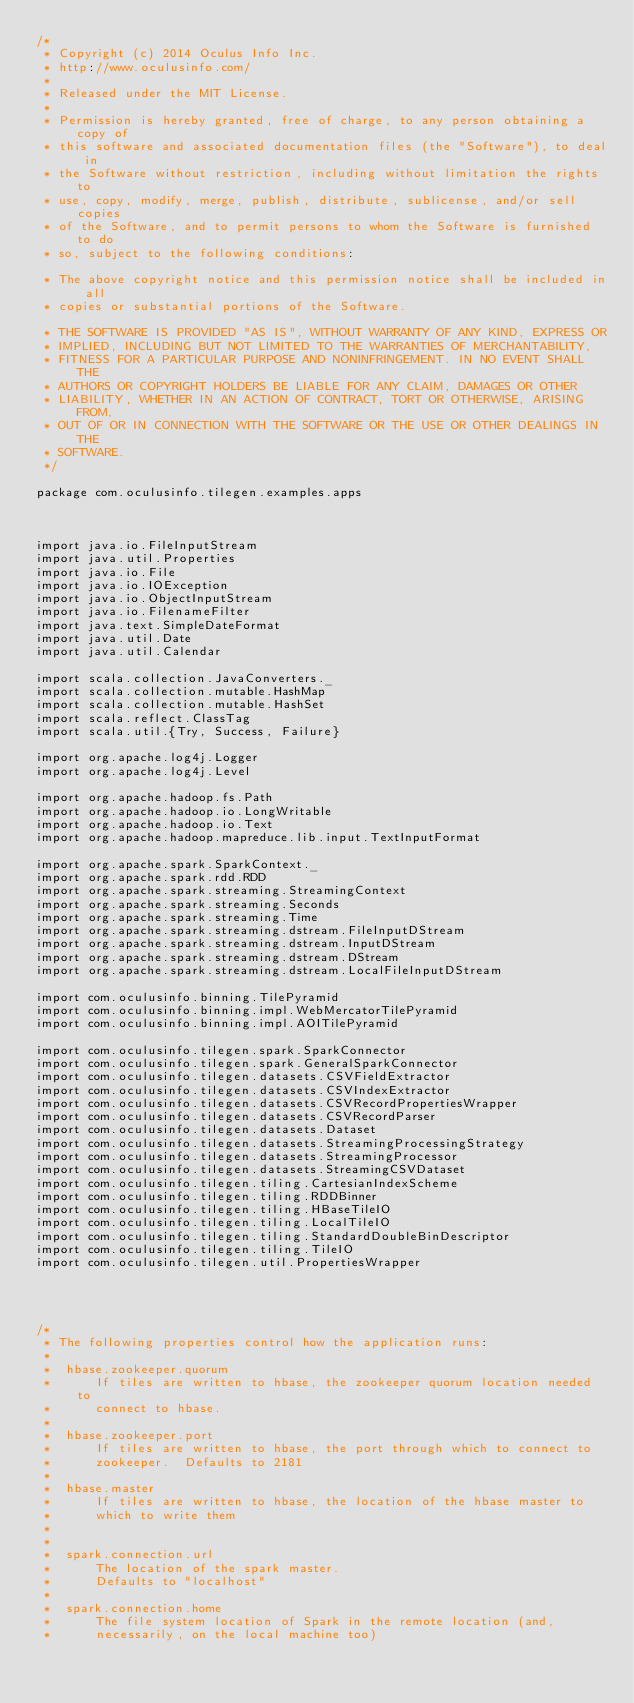Convert code to text. <code><loc_0><loc_0><loc_500><loc_500><_Scala_>/*
 * Copyright (c) 2014 Oculus Info Inc.
 * http://www.oculusinfo.com/
 *
 * Released under the MIT License.
 *
 * Permission is hereby granted, free of charge, to any person obtaining a copy of
 * this software and associated documentation files (the "Software"), to deal in
 * the Software without restriction, including without limitation the rights to
 * use, copy, modify, merge, publish, distribute, sublicense, and/or sell copies
 * of the Software, and to permit persons to whom the Software is furnished to do
 * so, subject to the following conditions:

 * The above copyright notice and this permission notice shall be included in all
 * copies or substantial portions of the Software.

 * THE SOFTWARE IS PROVIDED "AS IS", WITHOUT WARRANTY OF ANY KIND, EXPRESS OR
 * IMPLIED, INCLUDING BUT NOT LIMITED TO THE WARRANTIES OF MERCHANTABILITY,
 * FITNESS FOR A PARTICULAR PURPOSE AND NONINFRINGEMENT. IN NO EVENT SHALL THE
 * AUTHORS OR COPYRIGHT HOLDERS BE LIABLE FOR ANY CLAIM, DAMAGES OR OTHER
 * LIABILITY, WHETHER IN AN ACTION OF CONTRACT, TORT OR OTHERWISE, ARISING FROM,
 * OUT OF OR IN CONNECTION WITH THE SOFTWARE OR THE USE OR OTHER DEALINGS IN THE
 * SOFTWARE.
 */

package com.oculusinfo.tilegen.examples.apps



import java.io.FileInputStream
import java.util.Properties
import java.io.File
import java.io.IOException
import java.io.ObjectInputStream
import java.io.FilenameFilter
import java.text.SimpleDateFormat
import java.util.Date
import java.util.Calendar

import scala.collection.JavaConverters._
import scala.collection.mutable.HashMap
import scala.collection.mutable.HashSet
import scala.reflect.ClassTag
import scala.util.{Try, Success, Failure}

import org.apache.log4j.Logger
import org.apache.log4j.Level

import org.apache.hadoop.fs.Path
import org.apache.hadoop.io.LongWritable
import org.apache.hadoop.io.Text
import org.apache.hadoop.mapreduce.lib.input.TextInputFormat

import org.apache.spark.SparkContext._
import org.apache.spark.rdd.RDD
import org.apache.spark.streaming.StreamingContext
import org.apache.spark.streaming.Seconds
import org.apache.spark.streaming.Time
import org.apache.spark.streaming.dstream.FileInputDStream
import org.apache.spark.streaming.dstream.InputDStream
import org.apache.spark.streaming.dstream.DStream
import org.apache.spark.streaming.dstream.LocalFileInputDStream

import com.oculusinfo.binning.TilePyramid
import com.oculusinfo.binning.impl.WebMercatorTilePyramid
import com.oculusinfo.binning.impl.AOITilePyramid

import com.oculusinfo.tilegen.spark.SparkConnector
import com.oculusinfo.tilegen.spark.GeneralSparkConnector
import com.oculusinfo.tilegen.datasets.CSVFieldExtractor
import com.oculusinfo.tilegen.datasets.CSVIndexExtractor
import com.oculusinfo.tilegen.datasets.CSVRecordPropertiesWrapper
import com.oculusinfo.tilegen.datasets.CSVRecordParser
import com.oculusinfo.tilegen.datasets.Dataset
import com.oculusinfo.tilegen.datasets.StreamingProcessingStrategy
import com.oculusinfo.tilegen.datasets.StreamingProcessor
import com.oculusinfo.tilegen.datasets.StreamingCSVDataset
import com.oculusinfo.tilegen.tiling.CartesianIndexScheme
import com.oculusinfo.tilegen.tiling.RDDBinner
import com.oculusinfo.tilegen.tiling.HBaseTileIO
import com.oculusinfo.tilegen.tiling.LocalTileIO
import com.oculusinfo.tilegen.tiling.StandardDoubleBinDescriptor
import com.oculusinfo.tilegen.tiling.TileIO
import com.oculusinfo.tilegen.util.PropertiesWrapper




/*
 * The following properties control how the application runs:
 * 
 *  hbase.zookeeper.quorum
 *      If tiles are written to hbase, the zookeeper quorum location needed to
 *      connect to hbase.
 * 
 *  hbase.zookeeper.port
 *      If tiles are written to hbase, the port through which to connect to
 *      zookeeper.  Defaults to 2181
 * 
 *  hbase.master
 *      If tiles are written to hbase, the location of the hbase master to
 *      which to write them
 *
 * 
 *  spark.connection.url
 *      The location of the spark master.
 *      Defaults to "localhost"
 *
 *  spark.connection.home
 *      The file system location of Spark in the remote location (and,
 *      necessarily, on the local machine too)</code> 